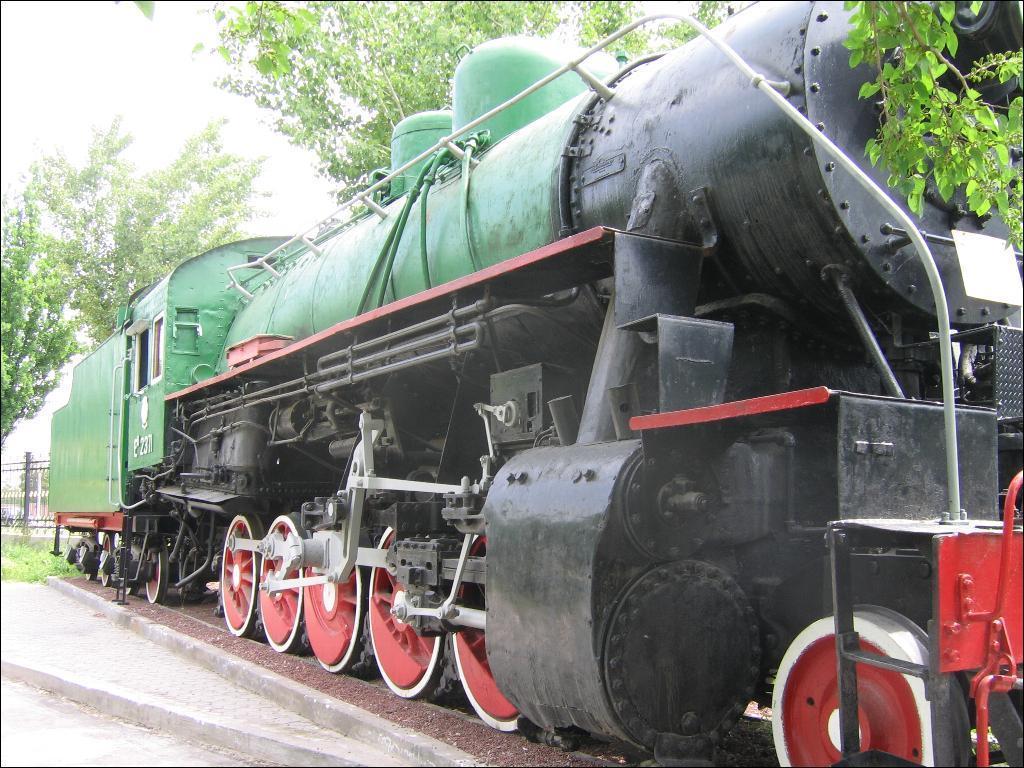In one or two sentences, can you explain what this image depicts? In this picture we can see a train engine on the right side, in the background there are some trees, we can see the sky at the left top of the picture. 